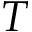<formula> <loc_0><loc_0><loc_500><loc_500>T</formula> 